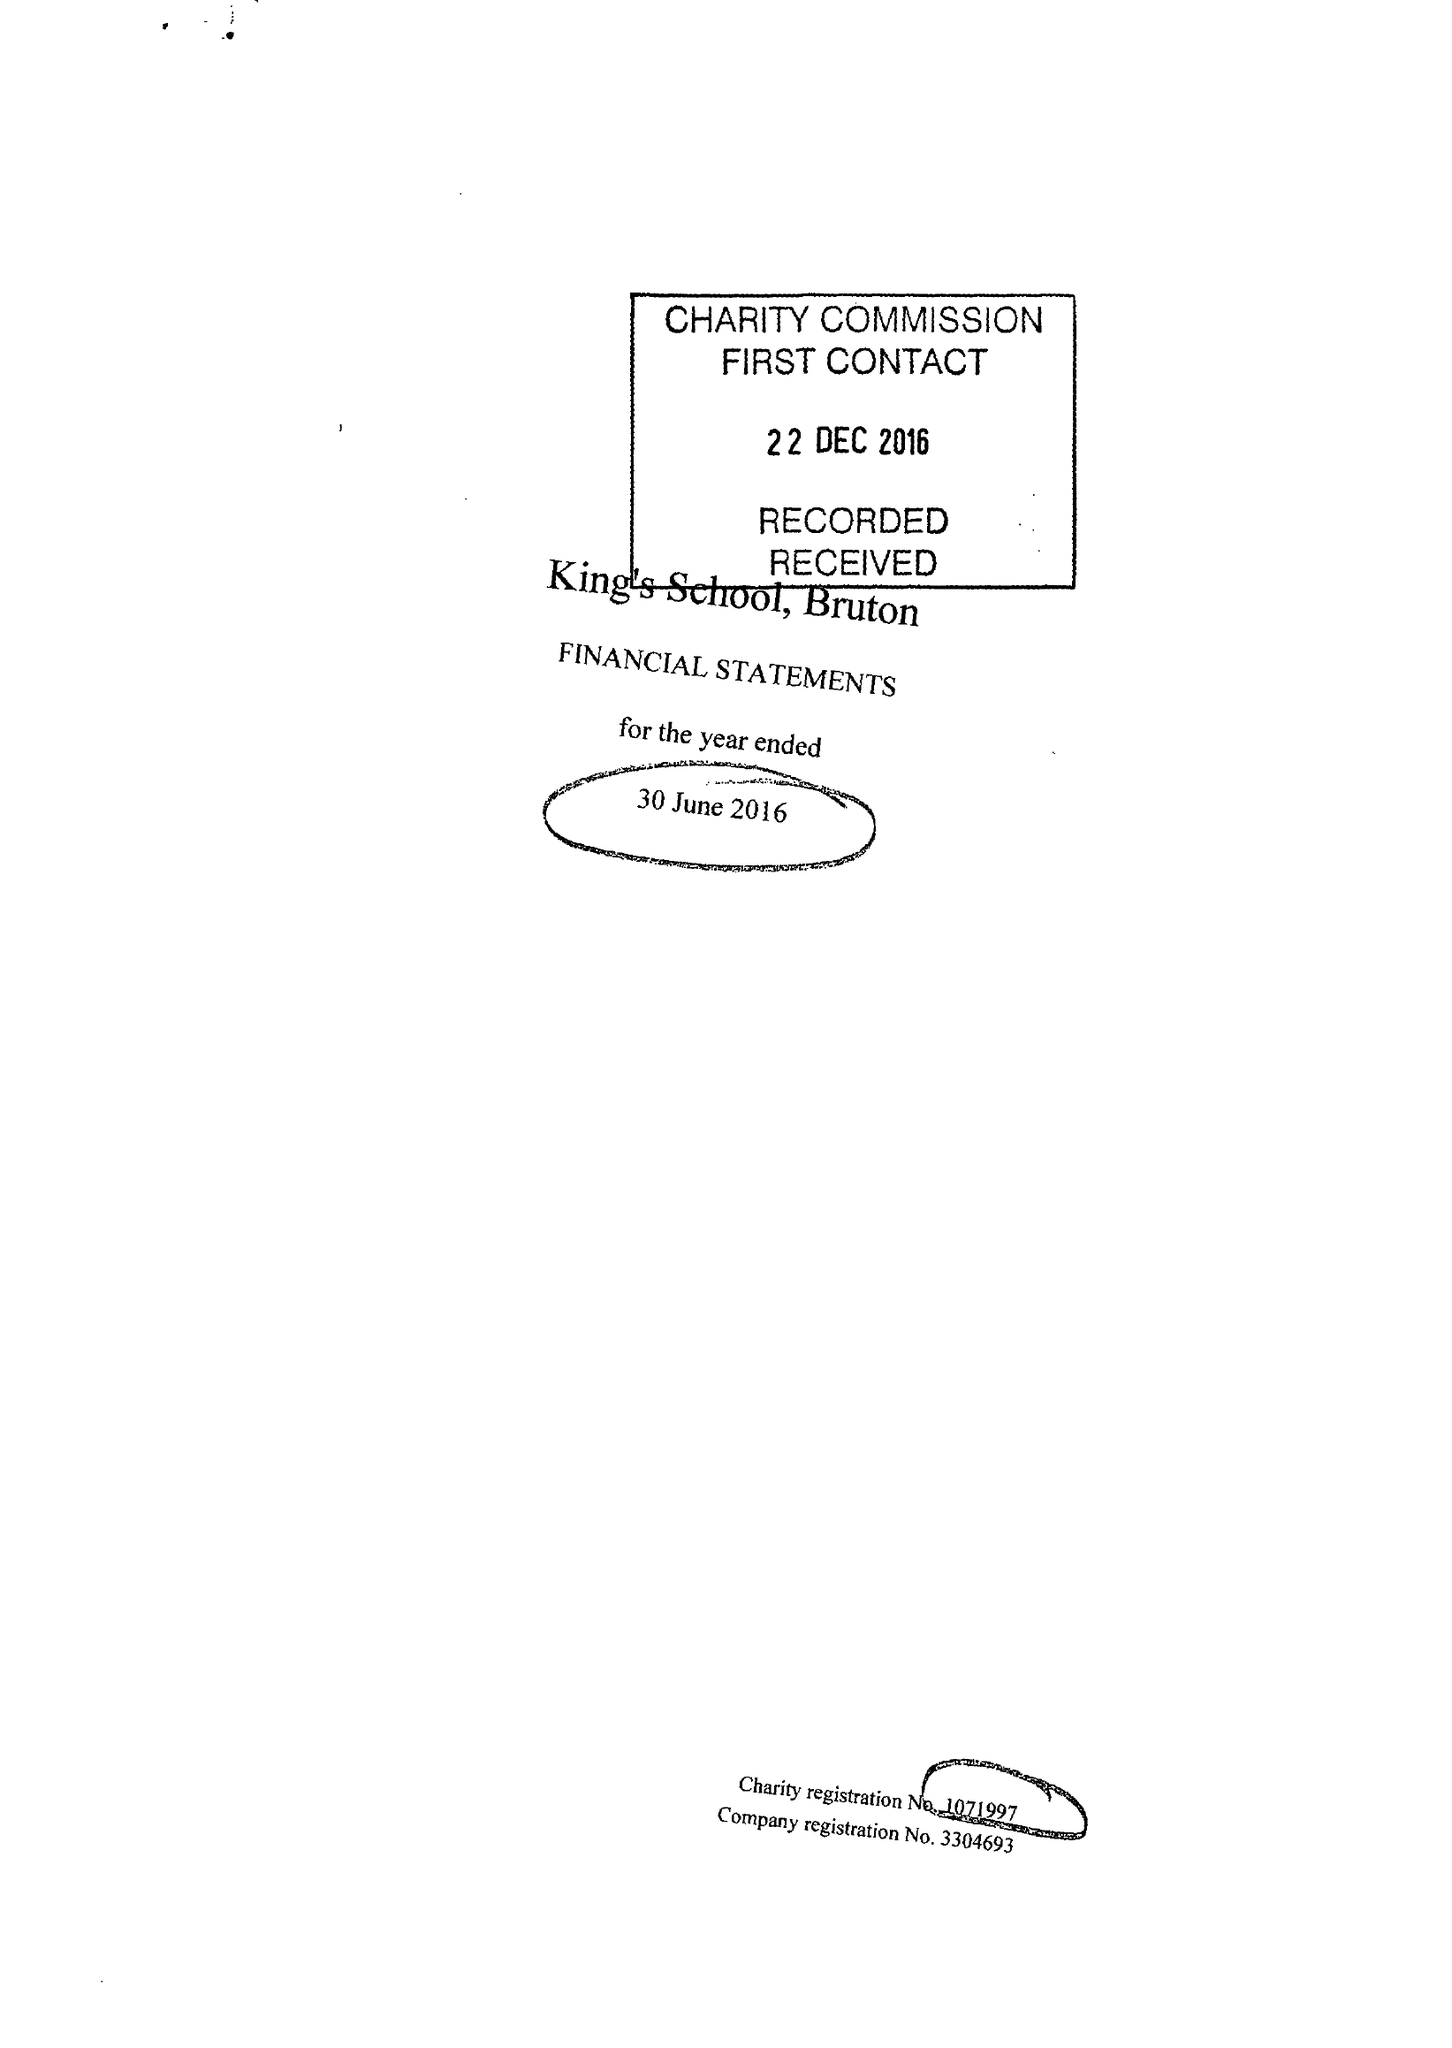What is the value for the report_date?
Answer the question using a single word or phrase. 2016-06-30 